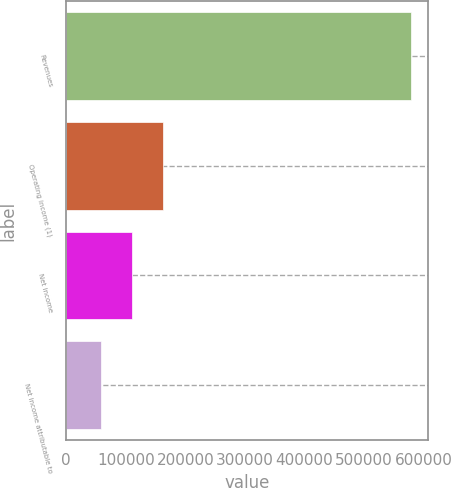Convert chart to OTSL. <chart><loc_0><loc_0><loc_500><loc_500><bar_chart><fcel>Revenues<fcel>Operating income (1)<fcel>Net income<fcel>Net income attributable to<nl><fcel>578746<fcel>162519<fcel>110490<fcel>58462<nl></chart> 